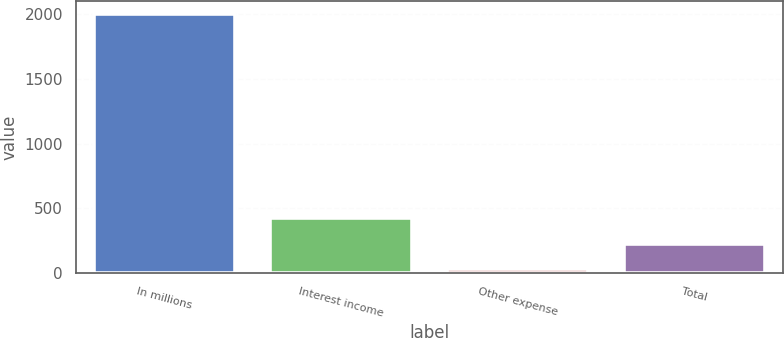Convert chart. <chart><loc_0><loc_0><loc_500><loc_500><bar_chart><fcel>In millions<fcel>Interest income<fcel>Other expense<fcel>Total<nl><fcel>2006<fcel>424.4<fcel>29<fcel>226.7<nl></chart> 